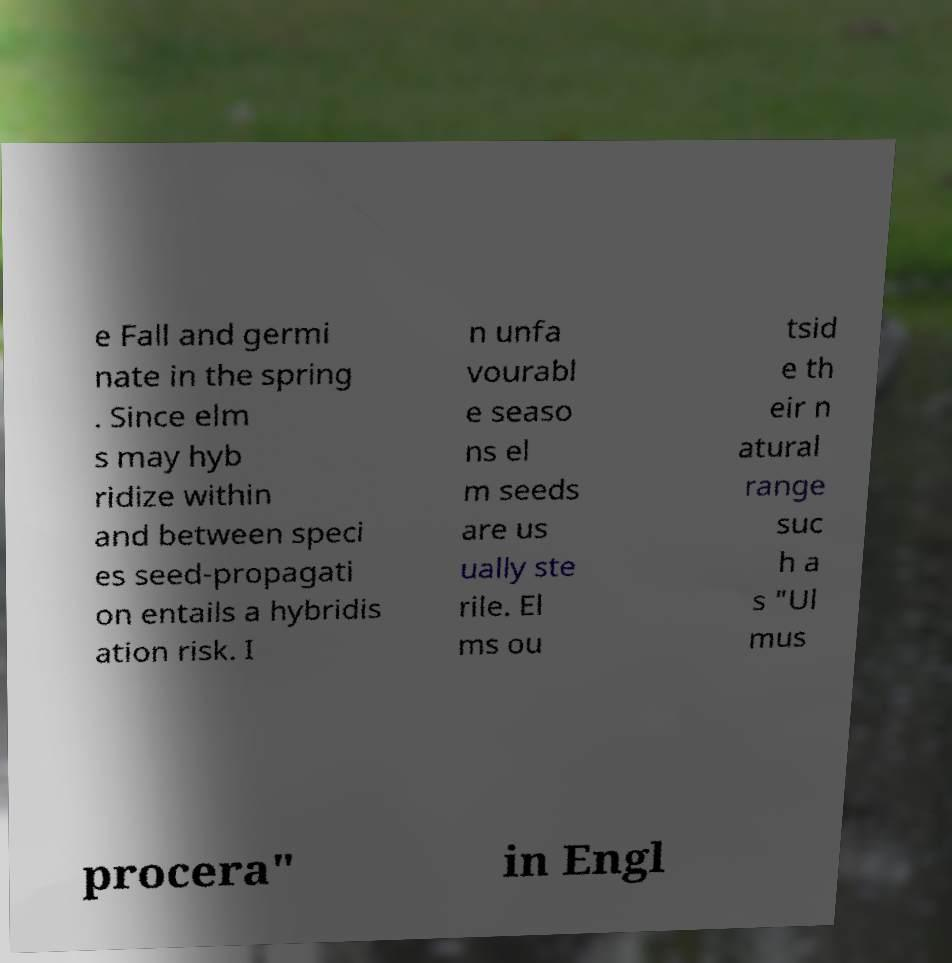Could you extract and type out the text from this image? e Fall and germi nate in the spring . Since elm s may hyb ridize within and between speci es seed-propagati on entails a hybridis ation risk. I n unfa vourabl e seaso ns el m seeds are us ually ste rile. El ms ou tsid e th eir n atural range suc h a s "Ul mus procera" in Engl 